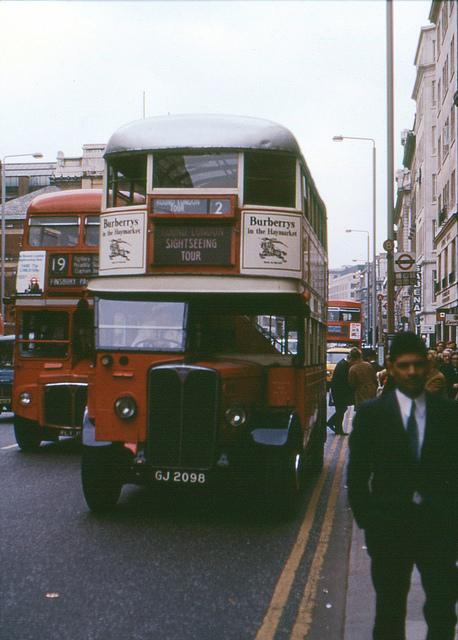Which country were we probably likely to see these old double decker buses?

Choices:
A) germany
B) france
C) uk
D) usa uk 